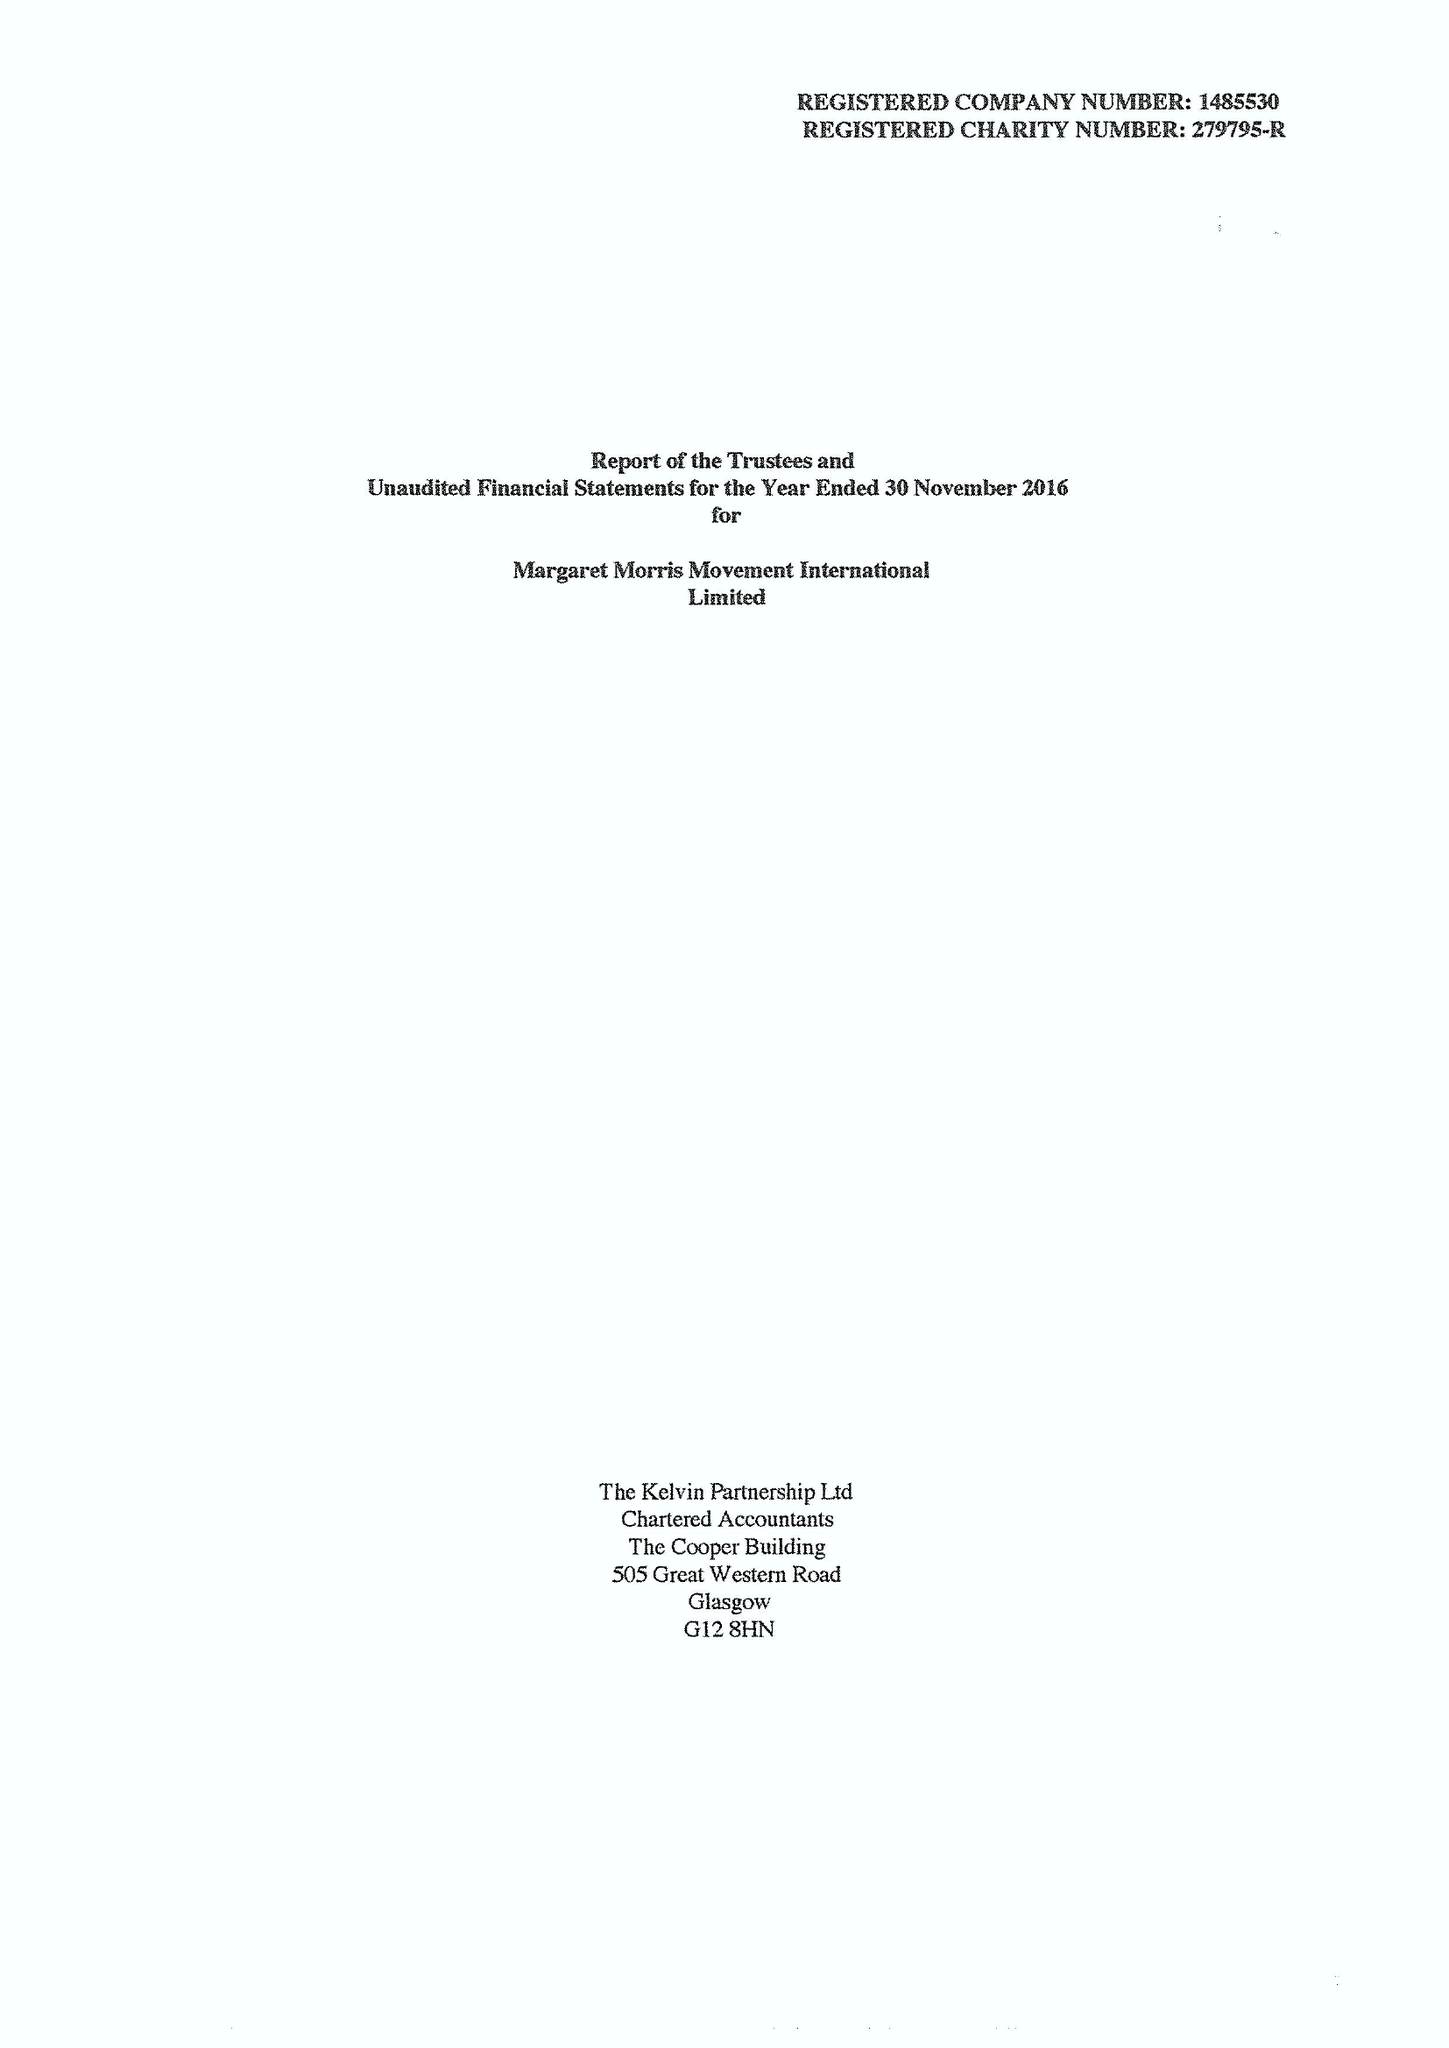What is the value for the charity_number?
Answer the question using a single word or phrase. 279795 